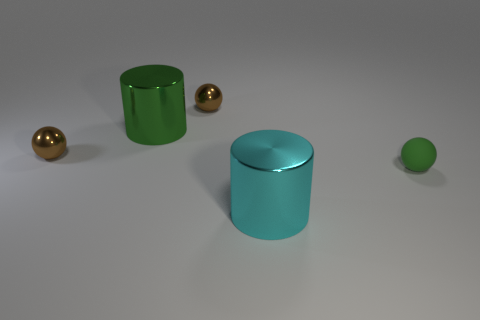There is a big cylinder right of the green metallic object; is there a brown ball that is in front of it? no 